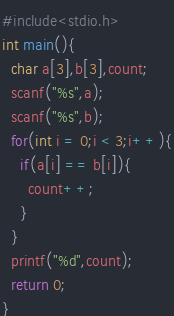Convert code to text. <code><loc_0><loc_0><loc_500><loc_500><_C_>#include<stdio.h>
int main(){
  char a[3],b[3],count;
  scanf("%s",a);
  scanf("%s",b);
  for(int i = 0;i < 3;i++){
    if(a[i] == b[i]){
      count++;
    }
  }
  printf("%d",count);
  return 0;
}
</code> 